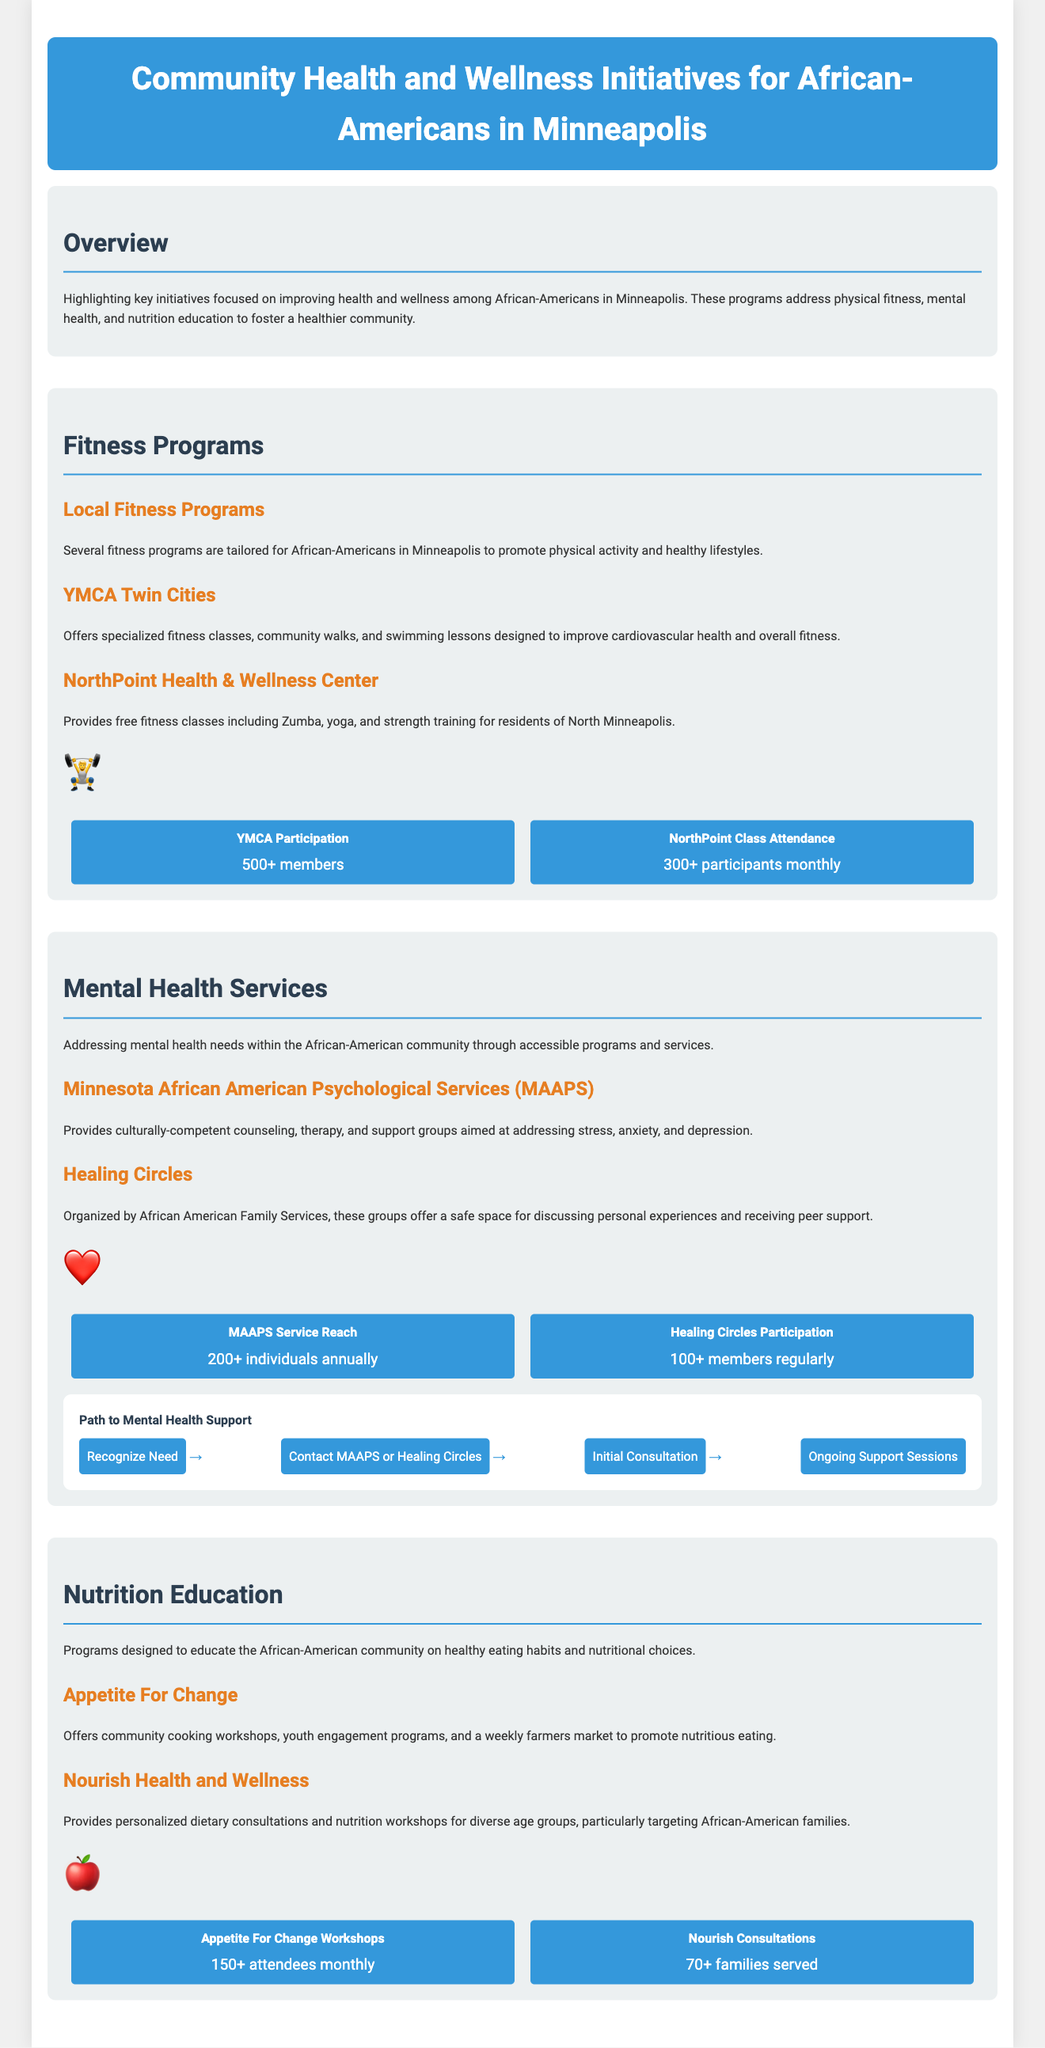What is the title of the document? The title of the document is presented at the top in large letters.
Answer: Community Health and Wellness Initiatives for African-Americans in Minneapolis How many fitness classes does NorthPoint Health & Wellness Center offer? NorthPoint offers free fitness classes including Zumba, yoga, and strength training, but the exact number is not specified.
Answer: Free fitness classes What is the participation rate for Appetite For Change workshops? The document specifies that there are over 150 attendees monthly for the workshops.
Answer: 150+ attendees monthly What organization provides culturally-competent mental health services? The document identifies Minnesota African American Psychological Services (MAAPS) as the provider of these services.
Answer: MAAPS What is the annual service reach of MAAPS? In the document, it states that MAAPS reaches over 200 individuals each year.
Answer: 200+ individuals annually Which program offers a weekly farmers market? Appetite For Change is highlighted as the organization that offers a weekly farmers market as part of its initiatives.
Answer: Appetite For Change How many families does Nourish Health and Wellness serve? The document states that Nourish Health and Wellness serves over 70 families with its consultations.
Answer: 70+ families served What is the symbol for mental health services in the document? An icon representing mental health services is used, and it's depicted as a heart.
Answer: ❤️ What is the primary focus of fitness programs mentioned in the document? The primary focus is to promote physical activity and healthy lifestyles among community members.
Answer: Physical activity and healthy lifestyles 